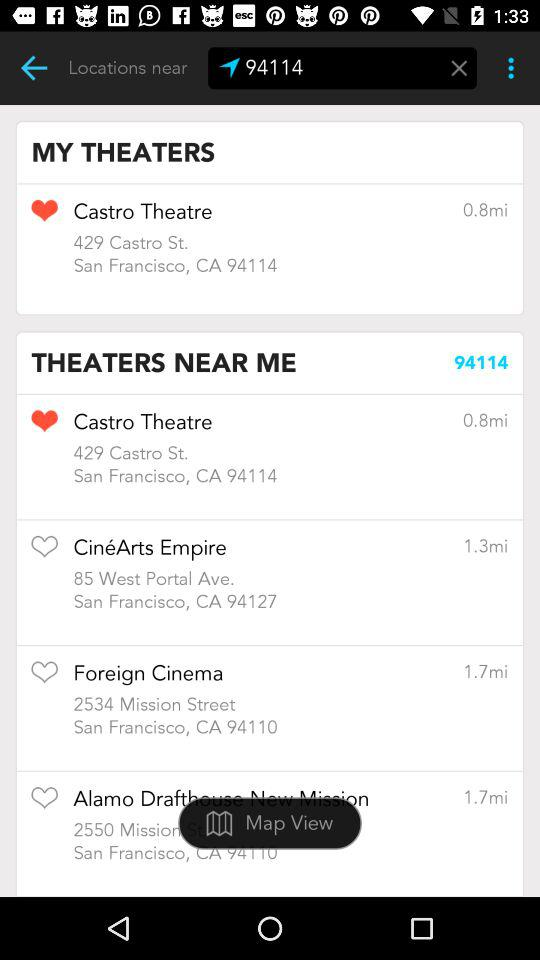How far is Foreign Cinema? Foreign Cinema is 1.7 miles away. 